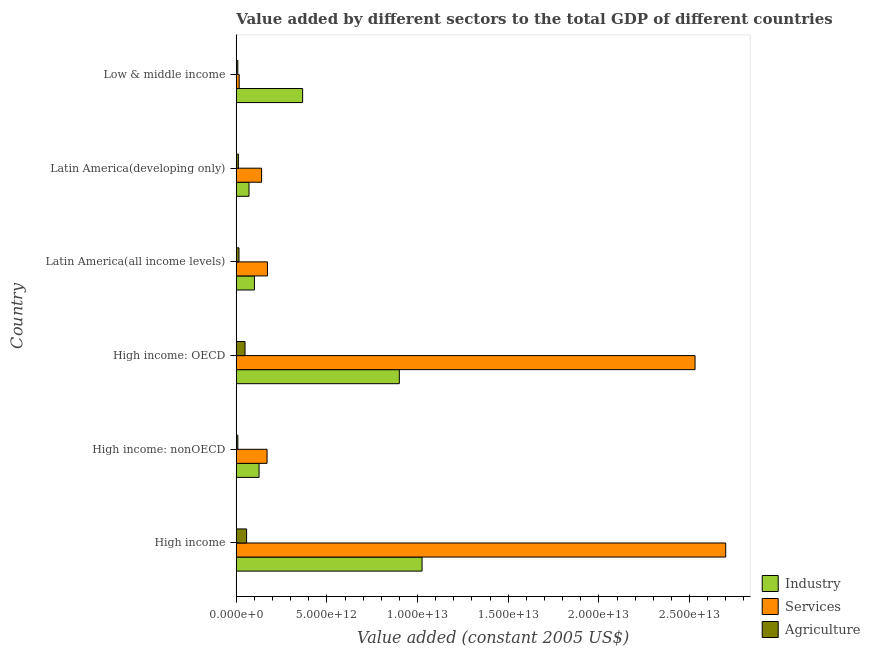Are the number of bars on each tick of the Y-axis equal?
Offer a very short reply. Yes. How many bars are there on the 2nd tick from the bottom?
Make the answer very short. 3. What is the label of the 6th group of bars from the top?
Give a very brief answer. High income. In how many cases, is the number of bars for a given country not equal to the number of legend labels?
Ensure brevity in your answer.  0. What is the value added by industrial sector in High income: nonOECD?
Offer a terse response. 1.26e+12. Across all countries, what is the maximum value added by services?
Your response must be concise. 2.70e+13. Across all countries, what is the minimum value added by industrial sector?
Provide a short and direct response. 7.03e+11. What is the total value added by agricultural sector in the graph?
Provide a short and direct response. 1.50e+12. What is the difference between the value added by services in Latin America(all income levels) and that in Latin America(developing only)?
Ensure brevity in your answer.  3.21e+11. What is the difference between the value added by agricultural sector in Low & middle income and the value added by services in Latin America(developing only)?
Ensure brevity in your answer.  -1.31e+12. What is the average value added by agricultural sector per country?
Provide a short and direct response. 2.49e+11. What is the difference between the value added by services and value added by industrial sector in High income: nonOECD?
Provide a short and direct response. 4.41e+11. Is the value added by agricultural sector in High income: OECD less than that in High income: nonOECD?
Offer a terse response. No. Is the difference between the value added by services in High income: OECD and Low & middle income greater than the difference between the value added by industrial sector in High income: OECD and Low & middle income?
Offer a very short reply. Yes. What is the difference between the highest and the second highest value added by industrial sector?
Make the answer very short. 1.26e+12. What is the difference between the highest and the lowest value added by agricultural sector?
Keep it short and to the point. 4.85e+11. What does the 3rd bar from the top in Low & middle income represents?
Provide a short and direct response. Industry. What does the 3rd bar from the bottom in Latin America(all income levels) represents?
Your answer should be very brief. Agriculture. How many countries are there in the graph?
Offer a terse response. 6. What is the difference between two consecutive major ticks on the X-axis?
Keep it short and to the point. 5.00e+12. Are the values on the major ticks of X-axis written in scientific E-notation?
Keep it short and to the point. Yes. How many legend labels are there?
Your answer should be compact. 3. What is the title of the graph?
Keep it short and to the point. Value added by different sectors to the total GDP of different countries. Does "Machinery" appear as one of the legend labels in the graph?
Your response must be concise. No. What is the label or title of the X-axis?
Give a very brief answer. Value added (constant 2005 US$). What is the label or title of the Y-axis?
Provide a succinct answer. Country. What is the Value added (constant 2005 US$) of Industry in High income?
Offer a very short reply. 1.02e+13. What is the Value added (constant 2005 US$) in Services in High income?
Give a very brief answer. 2.70e+13. What is the Value added (constant 2005 US$) in Agriculture in High income?
Ensure brevity in your answer.  5.71e+11. What is the Value added (constant 2005 US$) in Industry in High income: nonOECD?
Provide a succinct answer. 1.26e+12. What is the Value added (constant 2005 US$) of Services in High income: nonOECD?
Make the answer very short. 1.70e+12. What is the Value added (constant 2005 US$) in Agriculture in High income: nonOECD?
Offer a terse response. 8.77e+1. What is the Value added (constant 2005 US$) of Industry in High income: OECD?
Keep it short and to the point. 8.99e+12. What is the Value added (constant 2005 US$) in Services in High income: OECD?
Ensure brevity in your answer.  2.53e+13. What is the Value added (constant 2005 US$) of Agriculture in High income: OECD?
Give a very brief answer. 4.83e+11. What is the Value added (constant 2005 US$) in Industry in Latin America(all income levels)?
Make the answer very short. 1.00e+12. What is the Value added (constant 2005 US$) in Services in Latin America(all income levels)?
Your response must be concise. 1.72e+12. What is the Value added (constant 2005 US$) in Agriculture in Latin America(all income levels)?
Ensure brevity in your answer.  1.51e+11. What is the Value added (constant 2005 US$) of Industry in Latin America(developing only)?
Provide a short and direct response. 7.03e+11. What is the Value added (constant 2005 US$) of Services in Latin America(developing only)?
Your response must be concise. 1.40e+12. What is the Value added (constant 2005 US$) of Agriculture in Latin America(developing only)?
Your answer should be compact. 1.19e+11. What is the Value added (constant 2005 US$) of Industry in Low & middle income?
Provide a succinct answer. 3.66e+12. What is the Value added (constant 2005 US$) of Services in Low & middle income?
Provide a succinct answer. 1.62e+11. What is the Value added (constant 2005 US$) of Agriculture in Low & middle income?
Your answer should be compact. 8.57e+1. Across all countries, what is the maximum Value added (constant 2005 US$) of Industry?
Your response must be concise. 1.02e+13. Across all countries, what is the maximum Value added (constant 2005 US$) of Services?
Provide a succinct answer. 2.70e+13. Across all countries, what is the maximum Value added (constant 2005 US$) in Agriculture?
Make the answer very short. 5.71e+11. Across all countries, what is the minimum Value added (constant 2005 US$) in Industry?
Make the answer very short. 7.03e+11. Across all countries, what is the minimum Value added (constant 2005 US$) in Services?
Give a very brief answer. 1.62e+11. Across all countries, what is the minimum Value added (constant 2005 US$) in Agriculture?
Offer a very short reply. 8.57e+1. What is the total Value added (constant 2005 US$) of Industry in the graph?
Ensure brevity in your answer.  2.59e+13. What is the total Value added (constant 2005 US$) of Services in the graph?
Your answer should be very brief. 5.73e+13. What is the total Value added (constant 2005 US$) in Agriculture in the graph?
Keep it short and to the point. 1.50e+12. What is the difference between the Value added (constant 2005 US$) in Industry in High income and that in High income: nonOECD?
Make the answer very short. 8.99e+12. What is the difference between the Value added (constant 2005 US$) of Services in High income and that in High income: nonOECD?
Provide a short and direct response. 2.53e+13. What is the difference between the Value added (constant 2005 US$) of Agriculture in High income and that in High income: nonOECD?
Offer a very short reply. 4.83e+11. What is the difference between the Value added (constant 2005 US$) in Industry in High income and that in High income: OECD?
Keep it short and to the point. 1.26e+12. What is the difference between the Value added (constant 2005 US$) of Services in High income and that in High income: OECD?
Offer a very short reply. 1.69e+12. What is the difference between the Value added (constant 2005 US$) of Agriculture in High income and that in High income: OECD?
Ensure brevity in your answer.  8.77e+1. What is the difference between the Value added (constant 2005 US$) in Industry in High income and that in Latin America(all income levels)?
Your response must be concise. 9.24e+12. What is the difference between the Value added (constant 2005 US$) in Services in High income and that in Latin America(all income levels)?
Your response must be concise. 2.53e+13. What is the difference between the Value added (constant 2005 US$) in Agriculture in High income and that in Latin America(all income levels)?
Make the answer very short. 4.20e+11. What is the difference between the Value added (constant 2005 US$) of Industry in High income and that in Latin America(developing only)?
Provide a short and direct response. 9.54e+12. What is the difference between the Value added (constant 2005 US$) in Services in High income and that in Latin America(developing only)?
Provide a succinct answer. 2.56e+13. What is the difference between the Value added (constant 2005 US$) of Agriculture in High income and that in Latin America(developing only)?
Make the answer very short. 4.52e+11. What is the difference between the Value added (constant 2005 US$) in Industry in High income and that in Low & middle income?
Give a very brief answer. 6.59e+12. What is the difference between the Value added (constant 2005 US$) in Services in High income and that in Low & middle income?
Your answer should be very brief. 2.68e+13. What is the difference between the Value added (constant 2005 US$) of Agriculture in High income and that in Low & middle income?
Make the answer very short. 4.85e+11. What is the difference between the Value added (constant 2005 US$) in Industry in High income: nonOECD and that in High income: OECD?
Offer a terse response. -7.73e+12. What is the difference between the Value added (constant 2005 US$) of Services in High income: nonOECD and that in High income: OECD?
Your response must be concise. -2.36e+13. What is the difference between the Value added (constant 2005 US$) of Agriculture in High income: nonOECD and that in High income: OECD?
Your response must be concise. -3.95e+11. What is the difference between the Value added (constant 2005 US$) in Industry in High income: nonOECD and that in Latin America(all income levels)?
Ensure brevity in your answer.  2.55e+11. What is the difference between the Value added (constant 2005 US$) of Services in High income: nonOECD and that in Latin America(all income levels)?
Offer a terse response. -2.07e+1. What is the difference between the Value added (constant 2005 US$) in Agriculture in High income: nonOECD and that in Latin America(all income levels)?
Give a very brief answer. -6.28e+1. What is the difference between the Value added (constant 2005 US$) of Industry in High income: nonOECD and that in Latin America(developing only)?
Your answer should be very brief. 5.54e+11. What is the difference between the Value added (constant 2005 US$) of Services in High income: nonOECD and that in Latin America(developing only)?
Provide a succinct answer. 3.00e+11. What is the difference between the Value added (constant 2005 US$) in Agriculture in High income: nonOECD and that in Latin America(developing only)?
Make the answer very short. -3.11e+1. What is the difference between the Value added (constant 2005 US$) in Industry in High income: nonOECD and that in Low & middle income?
Provide a short and direct response. -2.40e+12. What is the difference between the Value added (constant 2005 US$) in Services in High income: nonOECD and that in Low & middle income?
Your answer should be compact. 1.54e+12. What is the difference between the Value added (constant 2005 US$) of Agriculture in High income: nonOECD and that in Low & middle income?
Offer a very short reply. 2.03e+09. What is the difference between the Value added (constant 2005 US$) of Industry in High income: OECD and that in Latin America(all income levels)?
Your answer should be very brief. 7.99e+12. What is the difference between the Value added (constant 2005 US$) in Services in High income: OECD and that in Latin America(all income levels)?
Offer a very short reply. 2.36e+13. What is the difference between the Value added (constant 2005 US$) in Agriculture in High income: OECD and that in Latin America(all income levels)?
Offer a terse response. 3.33e+11. What is the difference between the Value added (constant 2005 US$) of Industry in High income: OECD and that in Latin America(developing only)?
Your answer should be very brief. 8.29e+12. What is the difference between the Value added (constant 2005 US$) in Services in High income: OECD and that in Latin America(developing only)?
Offer a terse response. 2.39e+13. What is the difference between the Value added (constant 2005 US$) of Agriculture in High income: OECD and that in Latin America(developing only)?
Offer a very short reply. 3.64e+11. What is the difference between the Value added (constant 2005 US$) of Industry in High income: OECD and that in Low & middle income?
Your answer should be very brief. 5.33e+12. What is the difference between the Value added (constant 2005 US$) of Services in High income: OECD and that in Low & middle income?
Ensure brevity in your answer.  2.51e+13. What is the difference between the Value added (constant 2005 US$) in Agriculture in High income: OECD and that in Low & middle income?
Your answer should be compact. 3.97e+11. What is the difference between the Value added (constant 2005 US$) of Industry in Latin America(all income levels) and that in Latin America(developing only)?
Provide a succinct answer. 3.00e+11. What is the difference between the Value added (constant 2005 US$) in Services in Latin America(all income levels) and that in Latin America(developing only)?
Ensure brevity in your answer.  3.21e+11. What is the difference between the Value added (constant 2005 US$) in Agriculture in Latin America(all income levels) and that in Latin America(developing only)?
Provide a short and direct response. 3.18e+1. What is the difference between the Value added (constant 2005 US$) of Industry in Latin America(all income levels) and that in Low & middle income?
Your response must be concise. -2.66e+12. What is the difference between the Value added (constant 2005 US$) in Services in Latin America(all income levels) and that in Low & middle income?
Your response must be concise. 1.56e+12. What is the difference between the Value added (constant 2005 US$) of Agriculture in Latin America(all income levels) and that in Low & middle income?
Provide a succinct answer. 6.49e+1. What is the difference between the Value added (constant 2005 US$) in Industry in Latin America(developing only) and that in Low & middle income?
Make the answer very short. -2.96e+12. What is the difference between the Value added (constant 2005 US$) in Services in Latin America(developing only) and that in Low & middle income?
Offer a very short reply. 1.24e+12. What is the difference between the Value added (constant 2005 US$) of Agriculture in Latin America(developing only) and that in Low & middle income?
Offer a terse response. 3.31e+1. What is the difference between the Value added (constant 2005 US$) in Industry in High income and the Value added (constant 2005 US$) in Services in High income: nonOECD?
Your answer should be compact. 8.55e+12. What is the difference between the Value added (constant 2005 US$) in Industry in High income and the Value added (constant 2005 US$) in Agriculture in High income: nonOECD?
Provide a succinct answer. 1.02e+13. What is the difference between the Value added (constant 2005 US$) in Services in High income and the Value added (constant 2005 US$) in Agriculture in High income: nonOECD?
Ensure brevity in your answer.  2.69e+13. What is the difference between the Value added (constant 2005 US$) in Industry in High income and the Value added (constant 2005 US$) in Services in High income: OECD?
Offer a terse response. -1.51e+13. What is the difference between the Value added (constant 2005 US$) of Industry in High income and the Value added (constant 2005 US$) of Agriculture in High income: OECD?
Your response must be concise. 9.76e+12. What is the difference between the Value added (constant 2005 US$) of Services in High income and the Value added (constant 2005 US$) of Agriculture in High income: OECD?
Your answer should be compact. 2.65e+13. What is the difference between the Value added (constant 2005 US$) in Industry in High income and the Value added (constant 2005 US$) in Services in Latin America(all income levels)?
Your response must be concise. 8.53e+12. What is the difference between the Value added (constant 2005 US$) of Industry in High income and the Value added (constant 2005 US$) of Agriculture in Latin America(all income levels)?
Provide a succinct answer. 1.01e+13. What is the difference between the Value added (constant 2005 US$) in Services in High income and the Value added (constant 2005 US$) in Agriculture in Latin America(all income levels)?
Your response must be concise. 2.68e+13. What is the difference between the Value added (constant 2005 US$) of Industry in High income and the Value added (constant 2005 US$) of Services in Latin America(developing only)?
Give a very brief answer. 8.85e+12. What is the difference between the Value added (constant 2005 US$) in Industry in High income and the Value added (constant 2005 US$) in Agriculture in Latin America(developing only)?
Your answer should be compact. 1.01e+13. What is the difference between the Value added (constant 2005 US$) of Services in High income and the Value added (constant 2005 US$) of Agriculture in Latin America(developing only)?
Your response must be concise. 2.69e+13. What is the difference between the Value added (constant 2005 US$) in Industry in High income and the Value added (constant 2005 US$) in Services in Low & middle income?
Provide a succinct answer. 1.01e+13. What is the difference between the Value added (constant 2005 US$) of Industry in High income and the Value added (constant 2005 US$) of Agriculture in Low & middle income?
Your answer should be very brief. 1.02e+13. What is the difference between the Value added (constant 2005 US$) of Services in High income and the Value added (constant 2005 US$) of Agriculture in Low & middle income?
Keep it short and to the point. 2.69e+13. What is the difference between the Value added (constant 2005 US$) of Industry in High income: nonOECD and the Value added (constant 2005 US$) of Services in High income: OECD?
Keep it short and to the point. -2.40e+13. What is the difference between the Value added (constant 2005 US$) of Industry in High income: nonOECD and the Value added (constant 2005 US$) of Agriculture in High income: OECD?
Provide a short and direct response. 7.75e+11. What is the difference between the Value added (constant 2005 US$) in Services in High income: nonOECD and the Value added (constant 2005 US$) in Agriculture in High income: OECD?
Provide a short and direct response. 1.22e+12. What is the difference between the Value added (constant 2005 US$) in Industry in High income: nonOECD and the Value added (constant 2005 US$) in Services in Latin America(all income levels)?
Your answer should be compact. -4.62e+11. What is the difference between the Value added (constant 2005 US$) in Industry in High income: nonOECD and the Value added (constant 2005 US$) in Agriculture in Latin America(all income levels)?
Give a very brief answer. 1.11e+12. What is the difference between the Value added (constant 2005 US$) in Services in High income: nonOECD and the Value added (constant 2005 US$) in Agriculture in Latin America(all income levels)?
Ensure brevity in your answer.  1.55e+12. What is the difference between the Value added (constant 2005 US$) in Industry in High income: nonOECD and the Value added (constant 2005 US$) in Services in Latin America(developing only)?
Your answer should be very brief. -1.41e+11. What is the difference between the Value added (constant 2005 US$) of Industry in High income: nonOECD and the Value added (constant 2005 US$) of Agriculture in Latin America(developing only)?
Give a very brief answer. 1.14e+12. What is the difference between the Value added (constant 2005 US$) in Services in High income: nonOECD and the Value added (constant 2005 US$) in Agriculture in Latin America(developing only)?
Make the answer very short. 1.58e+12. What is the difference between the Value added (constant 2005 US$) in Industry in High income: nonOECD and the Value added (constant 2005 US$) in Services in Low & middle income?
Your response must be concise. 1.10e+12. What is the difference between the Value added (constant 2005 US$) in Industry in High income: nonOECD and the Value added (constant 2005 US$) in Agriculture in Low & middle income?
Offer a terse response. 1.17e+12. What is the difference between the Value added (constant 2005 US$) of Services in High income: nonOECD and the Value added (constant 2005 US$) of Agriculture in Low & middle income?
Your answer should be compact. 1.61e+12. What is the difference between the Value added (constant 2005 US$) in Industry in High income: OECD and the Value added (constant 2005 US$) in Services in Latin America(all income levels)?
Offer a terse response. 7.27e+12. What is the difference between the Value added (constant 2005 US$) of Industry in High income: OECD and the Value added (constant 2005 US$) of Agriculture in Latin America(all income levels)?
Your answer should be compact. 8.84e+12. What is the difference between the Value added (constant 2005 US$) of Services in High income: OECD and the Value added (constant 2005 US$) of Agriculture in Latin America(all income levels)?
Give a very brief answer. 2.52e+13. What is the difference between the Value added (constant 2005 US$) of Industry in High income: OECD and the Value added (constant 2005 US$) of Services in Latin America(developing only)?
Give a very brief answer. 7.59e+12. What is the difference between the Value added (constant 2005 US$) in Industry in High income: OECD and the Value added (constant 2005 US$) in Agriculture in Latin America(developing only)?
Your answer should be very brief. 8.87e+12. What is the difference between the Value added (constant 2005 US$) in Services in High income: OECD and the Value added (constant 2005 US$) in Agriculture in Latin America(developing only)?
Provide a short and direct response. 2.52e+13. What is the difference between the Value added (constant 2005 US$) of Industry in High income: OECD and the Value added (constant 2005 US$) of Services in Low & middle income?
Offer a terse response. 8.83e+12. What is the difference between the Value added (constant 2005 US$) in Industry in High income: OECD and the Value added (constant 2005 US$) in Agriculture in Low & middle income?
Your answer should be very brief. 8.91e+12. What is the difference between the Value added (constant 2005 US$) in Services in High income: OECD and the Value added (constant 2005 US$) in Agriculture in Low & middle income?
Ensure brevity in your answer.  2.52e+13. What is the difference between the Value added (constant 2005 US$) of Industry in Latin America(all income levels) and the Value added (constant 2005 US$) of Services in Latin America(developing only)?
Offer a very short reply. -3.96e+11. What is the difference between the Value added (constant 2005 US$) in Industry in Latin America(all income levels) and the Value added (constant 2005 US$) in Agriculture in Latin America(developing only)?
Provide a succinct answer. 8.84e+11. What is the difference between the Value added (constant 2005 US$) in Services in Latin America(all income levels) and the Value added (constant 2005 US$) in Agriculture in Latin America(developing only)?
Your answer should be very brief. 1.60e+12. What is the difference between the Value added (constant 2005 US$) of Industry in Latin America(all income levels) and the Value added (constant 2005 US$) of Services in Low & middle income?
Make the answer very short. 8.41e+11. What is the difference between the Value added (constant 2005 US$) in Industry in Latin America(all income levels) and the Value added (constant 2005 US$) in Agriculture in Low & middle income?
Your answer should be compact. 9.17e+11. What is the difference between the Value added (constant 2005 US$) in Services in Latin America(all income levels) and the Value added (constant 2005 US$) in Agriculture in Low & middle income?
Give a very brief answer. 1.63e+12. What is the difference between the Value added (constant 2005 US$) in Industry in Latin America(developing only) and the Value added (constant 2005 US$) in Services in Low & middle income?
Offer a terse response. 5.42e+11. What is the difference between the Value added (constant 2005 US$) in Industry in Latin America(developing only) and the Value added (constant 2005 US$) in Agriculture in Low & middle income?
Offer a very short reply. 6.18e+11. What is the difference between the Value added (constant 2005 US$) in Services in Latin America(developing only) and the Value added (constant 2005 US$) in Agriculture in Low & middle income?
Offer a terse response. 1.31e+12. What is the average Value added (constant 2005 US$) in Industry per country?
Provide a succinct answer. 4.31e+12. What is the average Value added (constant 2005 US$) of Services per country?
Make the answer very short. 9.55e+12. What is the average Value added (constant 2005 US$) of Agriculture per country?
Keep it short and to the point. 2.49e+11. What is the difference between the Value added (constant 2005 US$) in Industry and Value added (constant 2005 US$) in Services in High income?
Give a very brief answer. -1.67e+13. What is the difference between the Value added (constant 2005 US$) of Industry and Value added (constant 2005 US$) of Agriculture in High income?
Offer a very short reply. 9.68e+12. What is the difference between the Value added (constant 2005 US$) of Services and Value added (constant 2005 US$) of Agriculture in High income?
Offer a terse response. 2.64e+13. What is the difference between the Value added (constant 2005 US$) in Industry and Value added (constant 2005 US$) in Services in High income: nonOECD?
Offer a terse response. -4.41e+11. What is the difference between the Value added (constant 2005 US$) of Industry and Value added (constant 2005 US$) of Agriculture in High income: nonOECD?
Keep it short and to the point. 1.17e+12. What is the difference between the Value added (constant 2005 US$) in Services and Value added (constant 2005 US$) in Agriculture in High income: nonOECD?
Your answer should be compact. 1.61e+12. What is the difference between the Value added (constant 2005 US$) in Industry and Value added (constant 2005 US$) in Services in High income: OECD?
Provide a short and direct response. -1.63e+13. What is the difference between the Value added (constant 2005 US$) of Industry and Value added (constant 2005 US$) of Agriculture in High income: OECD?
Give a very brief answer. 8.51e+12. What is the difference between the Value added (constant 2005 US$) in Services and Value added (constant 2005 US$) in Agriculture in High income: OECD?
Provide a short and direct response. 2.48e+13. What is the difference between the Value added (constant 2005 US$) of Industry and Value added (constant 2005 US$) of Services in Latin America(all income levels)?
Your response must be concise. -7.17e+11. What is the difference between the Value added (constant 2005 US$) of Industry and Value added (constant 2005 US$) of Agriculture in Latin America(all income levels)?
Offer a very short reply. 8.53e+11. What is the difference between the Value added (constant 2005 US$) of Services and Value added (constant 2005 US$) of Agriculture in Latin America(all income levels)?
Offer a very short reply. 1.57e+12. What is the difference between the Value added (constant 2005 US$) in Industry and Value added (constant 2005 US$) in Services in Latin America(developing only)?
Your answer should be compact. -6.95e+11. What is the difference between the Value added (constant 2005 US$) in Industry and Value added (constant 2005 US$) in Agriculture in Latin America(developing only)?
Give a very brief answer. 5.85e+11. What is the difference between the Value added (constant 2005 US$) in Services and Value added (constant 2005 US$) in Agriculture in Latin America(developing only)?
Offer a terse response. 1.28e+12. What is the difference between the Value added (constant 2005 US$) of Industry and Value added (constant 2005 US$) of Services in Low & middle income?
Your answer should be compact. 3.50e+12. What is the difference between the Value added (constant 2005 US$) of Industry and Value added (constant 2005 US$) of Agriculture in Low & middle income?
Your answer should be very brief. 3.57e+12. What is the difference between the Value added (constant 2005 US$) in Services and Value added (constant 2005 US$) in Agriculture in Low & middle income?
Give a very brief answer. 7.61e+1. What is the ratio of the Value added (constant 2005 US$) in Industry in High income to that in High income: nonOECD?
Your answer should be compact. 8.15. What is the ratio of the Value added (constant 2005 US$) of Services in High income to that in High income: nonOECD?
Provide a succinct answer. 15.89. What is the ratio of the Value added (constant 2005 US$) in Agriculture in High income to that in High income: nonOECD?
Ensure brevity in your answer.  6.51. What is the ratio of the Value added (constant 2005 US$) of Industry in High income to that in High income: OECD?
Make the answer very short. 1.14. What is the ratio of the Value added (constant 2005 US$) of Services in High income to that in High income: OECD?
Give a very brief answer. 1.07. What is the ratio of the Value added (constant 2005 US$) of Agriculture in High income to that in High income: OECD?
Your answer should be compact. 1.18. What is the ratio of the Value added (constant 2005 US$) in Industry in High income to that in Latin America(all income levels)?
Offer a terse response. 10.22. What is the ratio of the Value added (constant 2005 US$) in Services in High income to that in Latin America(all income levels)?
Make the answer very short. 15.7. What is the ratio of the Value added (constant 2005 US$) in Agriculture in High income to that in Latin America(all income levels)?
Offer a very short reply. 3.79. What is the ratio of the Value added (constant 2005 US$) of Industry in High income to that in Latin America(developing only)?
Your answer should be compact. 14.57. What is the ratio of the Value added (constant 2005 US$) in Services in High income to that in Latin America(developing only)?
Offer a very short reply. 19.3. What is the ratio of the Value added (constant 2005 US$) of Agriculture in High income to that in Latin America(developing only)?
Make the answer very short. 4.81. What is the ratio of the Value added (constant 2005 US$) of Industry in High income to that in Low & middle income?
Ensure brevity in your answer.  2.8. What is the ratio of the Value added (constant 2005 US$) of Services in High income to that in Low & middle income?
Give a very brief answer. 166.83. What is the ratio of the Value added (constant 2005 US$) in Agriculture in High income to that in Low & middle income?
Make the answer very short. 6.66. What is the ratio of the Value added (constant 2005 US$) of Industry in High income: nonOECD to that in High income: OECD?
Make the answer very short. 0.14. What is the ratio of the Value added (constant 2005 US$) in Services in High income: nonOECD to that in High income: OECD?
Provide a short and direct response. 0.07. What is the ratio of the Value added (constant 2005 US$) of Agriculture in High income: nonOECD to that in High income: OECD?
Your answer should be compact. 0.18. What is the ratio of the Value added (constant 2005 US$) in Industry in High income: nonOECD to that in Latin America(all income levels)?
Keep it short and to the point. 1.25. What is the ratio of the Value added (constant 2005 US$) in Services in High income: nonOECD to that in Latin America(all income levels)?
Make the answer very short. 0.99. What is the ratio of the Value added (constant 2005 US$) of Agriculture in High income: nonOECD to that in Latin America(all income levels)?
Your answer should be compact. 0.58. What is the ratio of the Value added (constant 2005 US$) of Industry in High income: nonOECD to that in Latin America(developing only)?
Your response must be concise. 1.79. What is the ratio of the Value added (constant 2005 US$) in Services in High income: nonOECD to that in Latin America(developing only)?
Give a very brief answer. 1.21. What is the ratio of the Value added (constant 2005 US$) in Agriculture in High income: nonOECD to that in Latin America(developing only)?
Your answer should be very brief. 0.74. What is the ratio of the Value added (constant 2005 US$) in Industry in High income: nonOECD to that in Low & middle income?
Your response must be concise. 0.34. What is the ratio of the Value added (constant 2005 US$) of Services in High income: nonOECD to that in Low & middle income?
Make the answer very short. 10.5. What is the ratio of the Value added (constant 2005 US$) in Agriculture in High income: nonOECD to that in Low & middle income?
Give a very brief answer. 1.02. What is the ratio of the Value added (constant 2005 US$) of Industry in High income: OECD to that in Latin America(all income levels)?
Ensure brevity in your answer.  8.96. What is the ratio of the Value added (constant 2005 US$) in Services in High income: OECD to that in Latin America(all income levels)?
Your answer should be very brief. 14.71. What is the ratio of the Value added (constant 2005 US$) of Agriculture in High income: OECD to that in Latin America(all income levels)?
Ensure brevity in your answer.  3.21. What is the ratio of the Value added (constant 2005 US$) in Industry in High income: OECD to that in Latin America(developing only)?
Your response must be concise. 12.78. What is the ratio of the Value added (constant 2005 US$) of Services in High income: OECD to that in Latin America(developing only)?
Your answer should be very brief. 18.09. What is the ratio of the Value added (constant 2005 US$) of Agriculture in High income: OECD to that in Latin America(developing only)?
Offer a terse response. 4.07. What is the ratio of the Value added (constant 2005 US$) in Industry in High income: OECD to that in Low & middle income?
Ensure brevity in your answer.  2.46. What is the ratio of the Value added (constant 2005 US$) of Services in High income: OECD to that in Low & middle income?
Make the answer very short. 156.37. What is the ratio of the Value added (constant 2005 US$) in Agriculture in High income: OECD to that in Low & middle income?
Provide a succinct answer. 5.64. What is the ratio of the Value added (constant 2005 US$) in Industry in Latin America(all income levels) to that in Latin America(developing only)?
Ensure brevity in your answer.  1.43. What is the ratio of the Value added (constant 2005 US$) of Services in Latin America(all income levels) to that in Latin America(developing only)?
Ensure brevity in your answer.  1.23. What is the ratio of the Value added (constant 2005 US$) of Agriculture in Latin America(all income levels) to that in Latin America(developing only)?
Give a very brief answer. 1.27. What is the ratio of the Value added (constant 2005 US$) in Industry in Latin America(all income levels) to that in Low & middle income?
Offer a very short reply. 0.27. What is the ratio of the Value added (constant 2005 US$) in Services in Latin America(all income levels) to that in Low & middle income?
Ensure brevity in your answer.  10.63. What is the ratio of the Value added (constant 2005 US$) of Agriculture in Latin America(all income levels) to that in Low & middle income?
Your response must be concise. 1.76. What is the ratio of the Value added (constant 2005 US$) of Industry in Latin America(developing only) to that in Low & middle income?
Ensure brevity in your answer.  0.19. What is the ratio of the Value added (constant 2005 US$) of Services in Latin America(developing only) to that in Low & middle income?
Your response must be concise. 8.64. What is the ratio of the Value added (constant 2005 US$) of Agriculture in Latin America(developing only) to that in Low & middle income?
Give a very brief answer. 1.39. What is the difference between the highest and the second highest Value added (constant 2005 US$) of Industry?
Ensure brevity in your answer.  1.26e+12. What is the difference between the highest and the second highest Value added (constant 2005 US$) in Services?
Your answer should be very brief. 1.69e+12. What is the difference between the highest and the second highest Value added (constant 2005 US$) of Agriculture?
Ensure brevity in your answer.  8.77e+1. What is the difference between the highest and the lowest Value added (constant 2005 US$) of Industry?
Give a very brief answer. 9.54e+12. What is the difference between the highest and the lowest Value added (constant 2005 US$) of Services?
Your answer should be very brief. 2.68e+13. What is the difference between the highest and the lowest Value added (constant 2005 US$) of Agriculture?
Your response must be concise. 4.85e+11. 